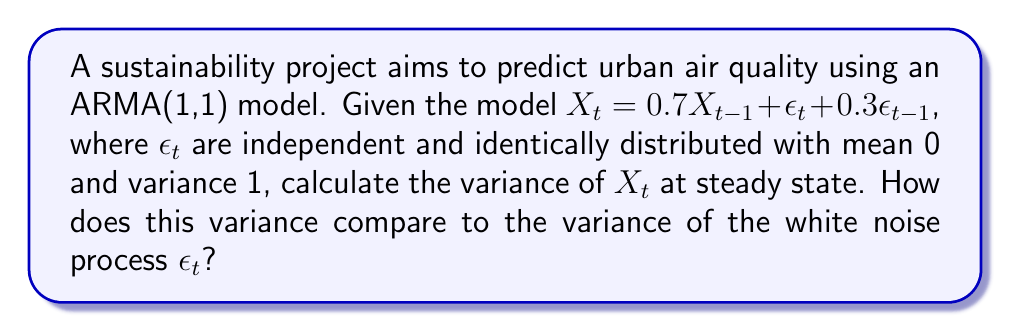Provide a solution to this math problem. To solve this problem, we'll follow these steps:

1) For an ARMA(1,1) process at steady state, the variance is given by:

   $$\text{Var}(X_t) = \frac{(1+2\phi\theta+\theta^2)\sigma_\epsilon^2}{1-\phi^2}$$

   where $\phi$ is the AR coefficient, $\theta$ is the MA coefficient, and $\sigma_\epsilon^2$ is the variance of the white noise process.

2) In our case, $\phi = 0.7$, $\theta = 0.3$, and $\sigma_\epsilon^2 = 1$.

3) Let's substitute these values into the formula:

   $$\text{Var}(X_t) = \frac{(1+2(0.7)(0.3)+0.3^2)1}{1-0.7^2}$$

4) Simplify:
   
   $$\text{Var}(X_t) = \frac{1+0.42+0.09}{1-0.49} = \frac{1.51}{0.51}$$

5) Calculate:
   
   $$\text{Var}(X_t) = 2.96$$

6) Compare this to the variance of $\epsilon_t$, which is 1:

   The variance of $X_t$ (2.96) is approximately 2.96 times larger than the variance of $\epsilon_t$ (1).

This increased variance demonstrates how the ARMA process amplifies the fluctuations in the white noise process, reflecting the complex dynamics of urban air quality.
Answer: $\text{Var}(X_t) = 2.96$, which is 2.96 times larger than $\text{Var}(\epsilon_t)$. 